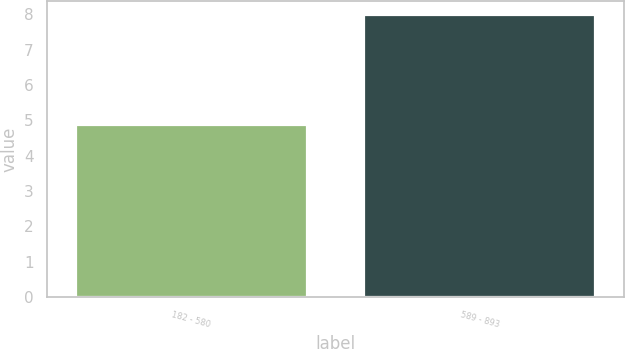Convert chart to OTSL. <chart><loc_0><loc_0><loc_500><loc_500><bar_chart><fcel>182 - 580<fcel>589 - 893<nl><fcel>4.88<fcel>7.99<nl></chart> 